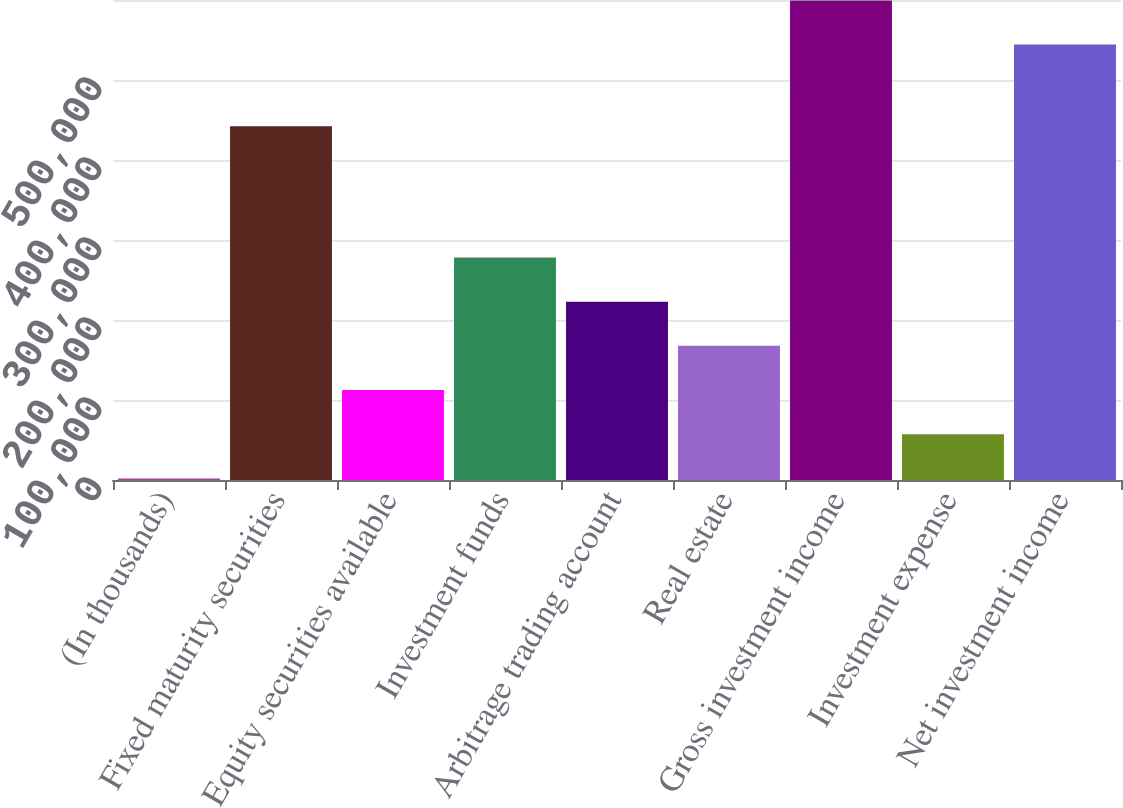Convert chart to OTSL. <chart><loc_0><loc_0><loc_500><loc_500><bar_chart><fcel>(In thousands)<fcel>Fixed maturity securities<fcel>Equity securities available<fcel>Investment funds<fcel>Arbitrage trading account<fcel>Real estate<fcel>Gross investment income<fcel>Investment expense<fcel>Net investment income<nl><fcel>2013<fcel>442287<fcel>112472<fcel>278160<fcel>222931<fcel>167702<fcel>599520<fcel>57242.5<fcel>544291<nl></chart> 